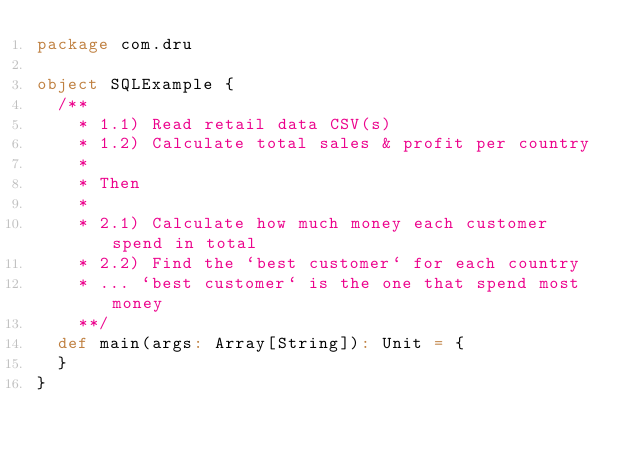<code> <loc_0><loc_0><loc_500><loc_500><_Scala_>package com.dru

object SQLExample {
  /**
    * 1.1) Read retail data CSV(s)
    * 1.2) Calculate total sales & profit per country
    *
    * Then
    *
    * 2.1) Calculate how much money each customer spend in total
    * 2.2) Find the `best customer` for each country
    * ... `best customer` is the one that spend most money
    **/
  def main(args: Array[String]): Unit = {
  }
}
</code> 